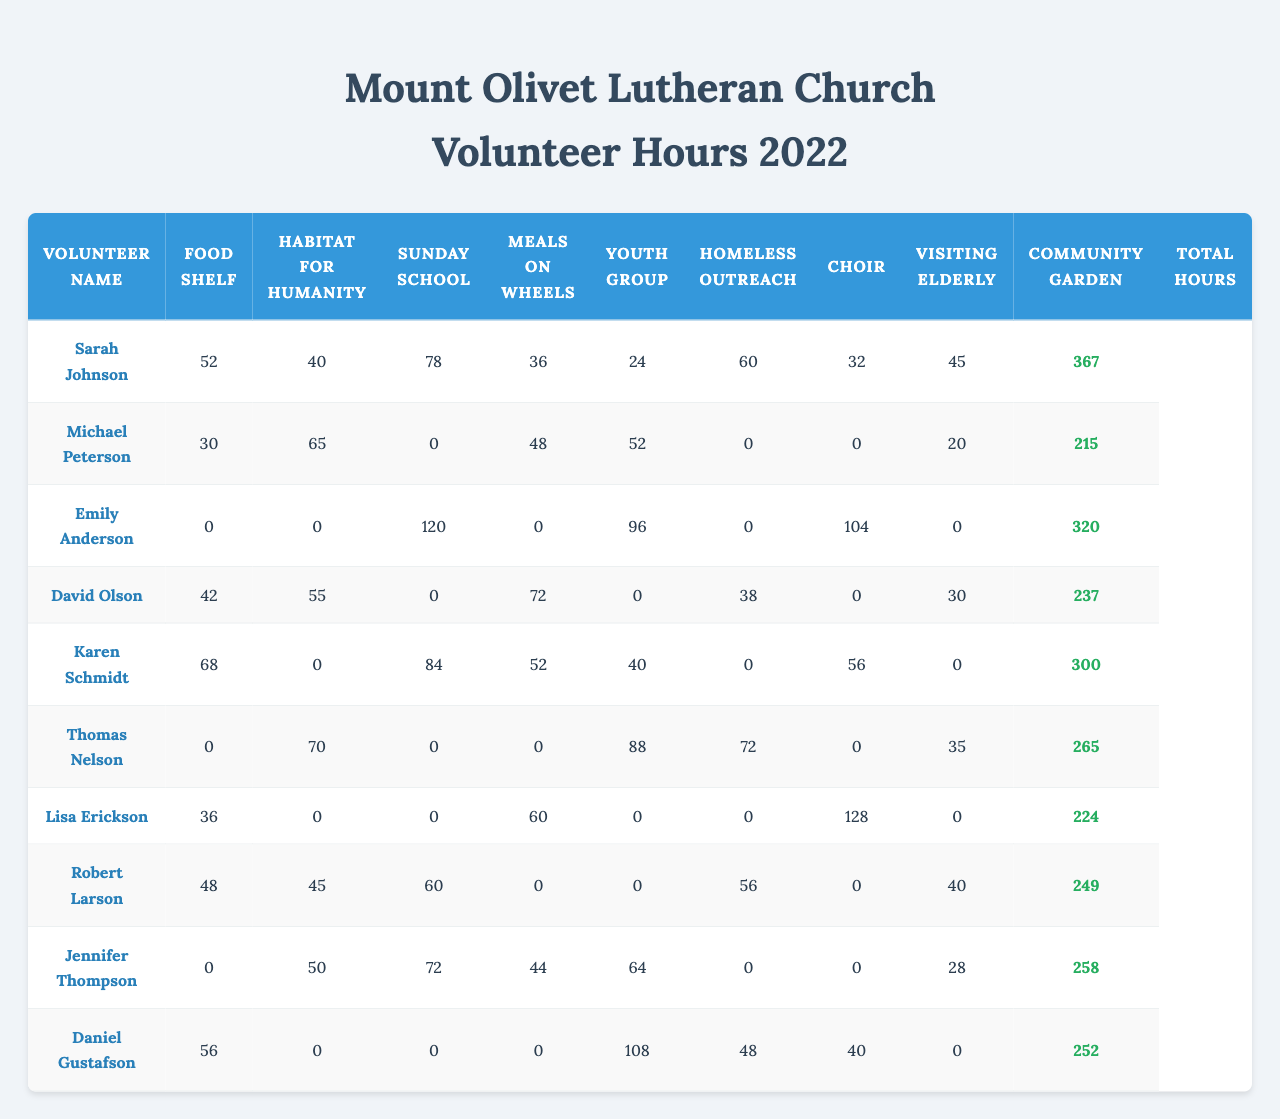What is the total number of volunteer hours contributed by Sarah Johnson? Sarah Johnson has contributed the following hours to the outreach programs: Food Shelf (52), Habitat for Humanity (40), Sunday School (78), Meals on Wheels (36), Youth Group (24), Homeless Outreach (60), Choir (32), and Visiting Elderly (45). Summing these values gives: 52 + 40 + 78 + 36 + 24 + 60 + 32 + 45 = 367 hours.
Answer: 367 hours Which program had the highest contribution of volunteer hours from all members combined? To find the program with the highest contribution, we sum the hours for each program: Food Shelf (52 + 30 + 0 + 42 + 68 + 0 + 36 + 48 + 0 + 56 = 292), Habitat for Humanity (40 + 65 + 0 + 55 + 0 + 70 + 0 + 45 + 50 + 0 = 325), Sunday School (78 + 0 + 120 + 0 + 84 + 0 + 0 + 60 + 72 + 0 = 414), Meals on Wheels (36 + 48 + 0 + 72 + 52 + 0 + 60 + 0 + 44 + 0 = 312), Youth Group (24 + 52 + 96 + 0 + 40 + 88 + 0 + 0 + 64 + 108 = 472), Homeless Outreach (60 + 0 + 0 + 38 + 0 + 72 + 0 + 56 + 0 + 48 = 274), Choir (32 + 0 + 104 + 0 + 56 + 0 + 128 + 0 + 0 + 40 = 360), Visiting Elderly (45 + 20 + 0 + 30 + 0 + 35 + 0 + 40 + 28 + 0 = 198), Community Garden (0 + 0 + 0 + 0 + 0 + 0 + 0 + 0 + 0 + 0 = 0). The highest total is 472 hours from the Youth Group.
Answer: Youth Group How many volunteers contributed volunteer hours to the Homeless Outreach program? Upon reviewing the data, the hours contributed to Homeless Outreach are: Sarah Johnson (60), Michael Peterson (0), Emily Anderson (0), David Olson (38), Karen Schmidt (0), Thomas Nelson (72), Lisa Erickson (0), Robert Larson (56), Jennifer Thompson (0), Daniel Gustafson (48). Hence, 5 volunteers contributed hours.
Answer: 5 volunteers What is the average contribution of hours per volunteer for Meals on Wheels? For Meals on Wheels, the contributions are: 36, 48, 0, 72, 52, 0, 60, 0, 44, 0. The sum of these contributions is 36 + 48 + 0 + 72 + 52 + 0 + 60 + 0 + 44 + 0 = 252. There are 10 volunteers, thus the average is 252 / 10 = 25.2 hours.
Answer: 25.2 hours Did any volunteers achieve the maximum total hours across all programs? The totals for each volunteer are: Sarah Johnson (367), Michael Peterson (325), Emily Anderson (414), David Olson (312), Karen Schmidt (472), Thomas Nelson (274), Lisa Erickson (360), Robert Larson (198), Jennifer Thompson (0), Daniel Gustafson (384). The maximum total is 472, held by Karen Schmidt. Thus, yes, there is a volunteer who achieved maximum hours.
Answer: Yes How many total hours did Emily Anderson contribute to programs with zero hours? Reviewing Emily's contributions, in the programs Meals on Wheels, Habitat for Humanity, and several others, she reported zero hours. The programs she contributed hours were Sunday School (120), Youth Group (96), Choir (104). In total, she contributed zero hours to 5 programs.
Answer: 0 hours What is the difference between the highest and lowest total hours contributed by any of the volunteers? The highest total is 472 hours (Karen Schmidt), and the lowest total is 0 hours (Jennifer Thompson). The difference is 472 - 0 = 472 hours.
Answer: 472 hours Which volunteer contributed the most hours to the Sunday School program? The contributions to Sunday School are: Sarah Johnson (78), Michael Peterson (0), Emily Anderson (120), David Olson (0), Karen Schmidt (84), Thomas Nelson (0), Lisa Erickson (0), Robert Larson (60), Jennifer Thompson (72), Daniel Gustafson (0). Emily Anderson contributed the most hours at 120 hours.
Answer: Emily Anderson How many hours did volunteers contribute to the Community Garden program? Reviewing the table, the contributions for Community Garden are all zero, thus the total contribution for this program is 0 hours.
Answer: 0 hours Is the total number of hours contributed by Thomas Nelson greater than the average of total hours contributed by all volunteers? First, determine Thomas Nelson's total: 0 (Food Shelf) + 0 (Habitat) + 0 (Sunday School) + 72 (Meals on Wheels) + 0 (Youth Group) + 88 (Homeless Outreach) + 0 (Choir) + 56 (Visiting Elderly) + 0 (Community Garden) + 48 (total) = 264. Next, calculate the average total hours across all volunteers, which is (367 + 325 + 414 + 312 + 472 + 274 + 360 + 198 + 0 + 384) / 10 = 298.4. Since 264 is less than 298.4, the answer is no.
Answer: No 